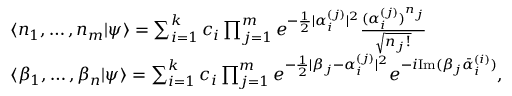<formula> <loc_0><loc_0><loc_500><loc_500>\begin{array} { r l } & { \langle n _ { 1 } , \dots , n _ { m } | \psi \rangle = \sum _ { i = 1 } ^ { k } c _ { i } \prod _ { j = 1 } ^ { m } e ^ { - \frac { 1 } { 2 } | \alpha _ { i } ^ { ( j ) } | ^ { 2 } } \frac { ( \alpha _ { i } ^ { ( j ) } ) ^ { n _ { j } } } { \sqrt { n _ { j } ! } } } \\ & { \langle \beta _ { 1 } , \dots , \beta _ { n } | \psi \rangle = \sum _ { i = 1 } ^ { k } c _ { i } \prod _ { j = 1 } ^ { m } e ^ { - \frac { 1 } { 2 } | \beta _ { j } - \alpha _ { i } ^ { ( j ) } | ^ { 2 } } e ^ { - i I m ( \beta _ { j } \bar { \alpha } _ { i } ^ { ( i ) } ) } , } \end{array}</formula> 